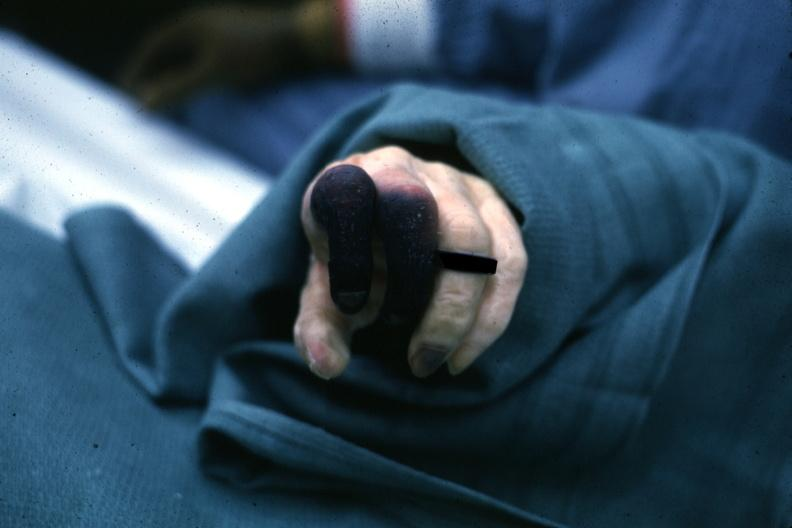does this image show well shown gangrene fingers?
Answer the question using a single word or phrase. Yes 